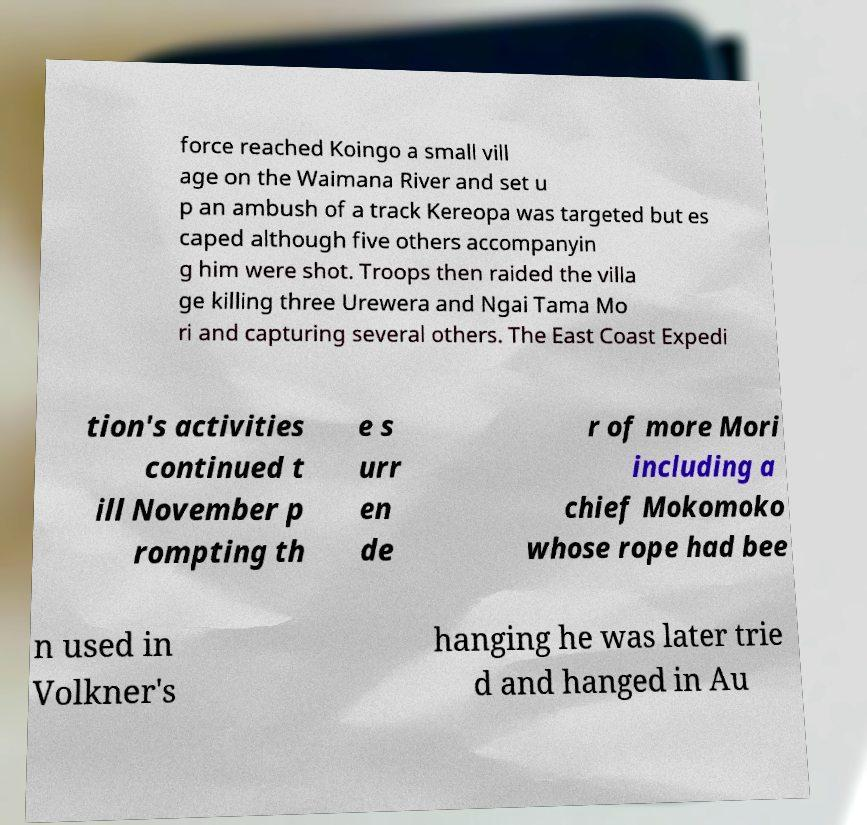Could you extract and type out the text from this image? force reached Koingo a small vill age on the Waimana River and set u p an ambush of a track Kereopa was targeted but es caped although five others accompanyin g him were shot. Troops then raided the villa ge killing three Urewera and Ngai Tama Mo ri and capturing several others. The East Coast Expedi tion's activities continued t ill November p rompting th e s urr en de r of more Mori including a chief Mokomoko whose rope had bee n used in Volkner's hanging he was later trie d and hanged in Au 